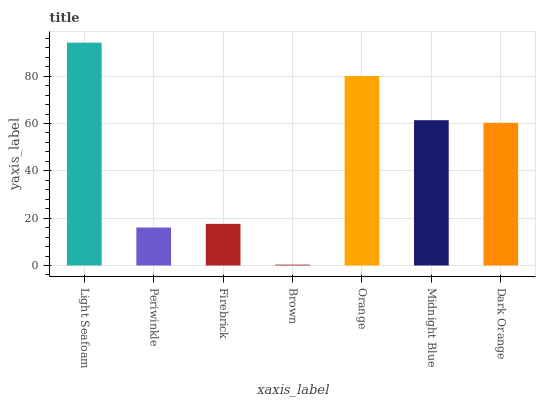Is Brown the minimum?
Answer yes or no. Yes. Is Light Seafoam the maximum?
Answer yes or no. Yes. Is Periwinkle the minimum?
Answer yes or no. No. Is Periwinkle the maximum?
Answer yes or no. No. Is Light Seafoam greater than Periwinkle?
Answer yes or no. Yes. Is Periwinkle less than Light Seafoam?
Answer yes or no. Yes. Is Periwinkle greater than Light Seafoam?
Answer yes or no. No. Is Light Seafoam less than Periwinkle?
Answer yes or no. No. Is Dark Orange the high median?
Answer yes or no. Yes. Is Dark Orange the low median?
Answer yes or no. Yes. Is Light Seafoam the high median?
Answer yes or no. No. Is Light Seafoam the low median?
Answer yes or no. No. 